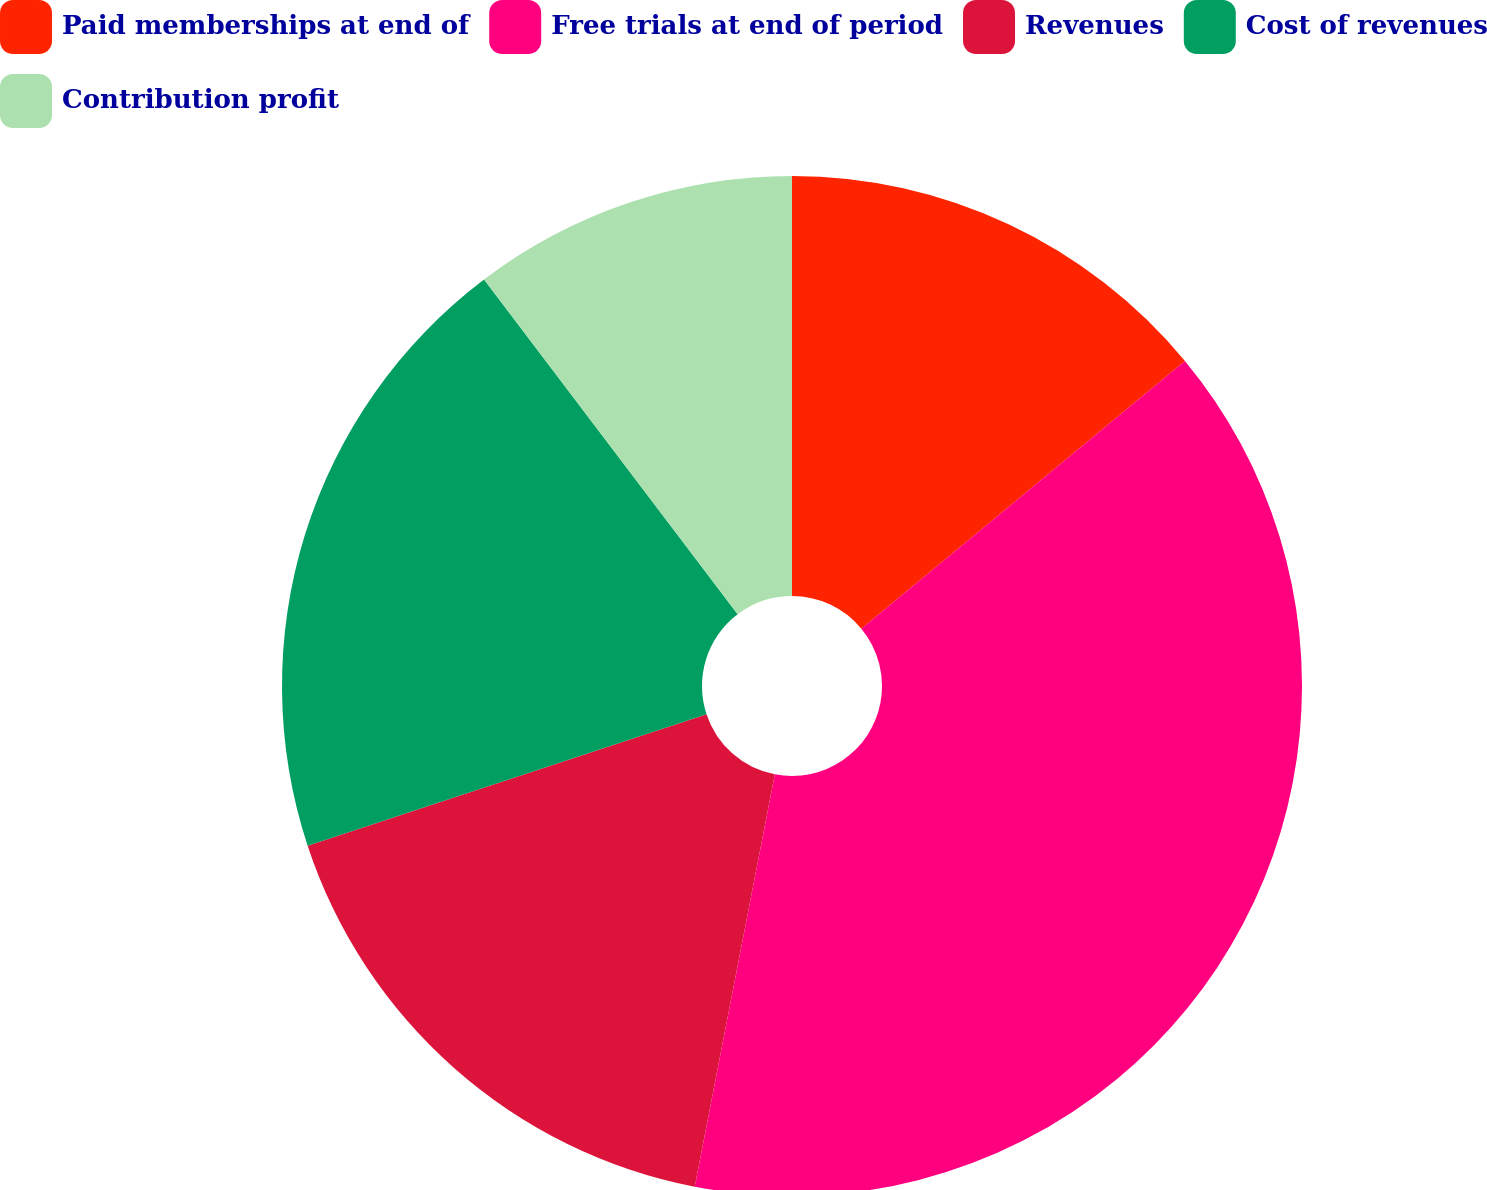Convert chart. <chart><loc_0><loc_0><loc_500><loc_500><pie_chart><fcel>Paid memberships at end of<fcel>Free trials at end of period<fcel>Revenues<fcel>Cost of revenues<fcel>Contribution profit<nl><fcel>14.0%<fcel>39.06%<fcel>16.88%<fcel>19.75%<fcel>10.32%<nl></chart> 